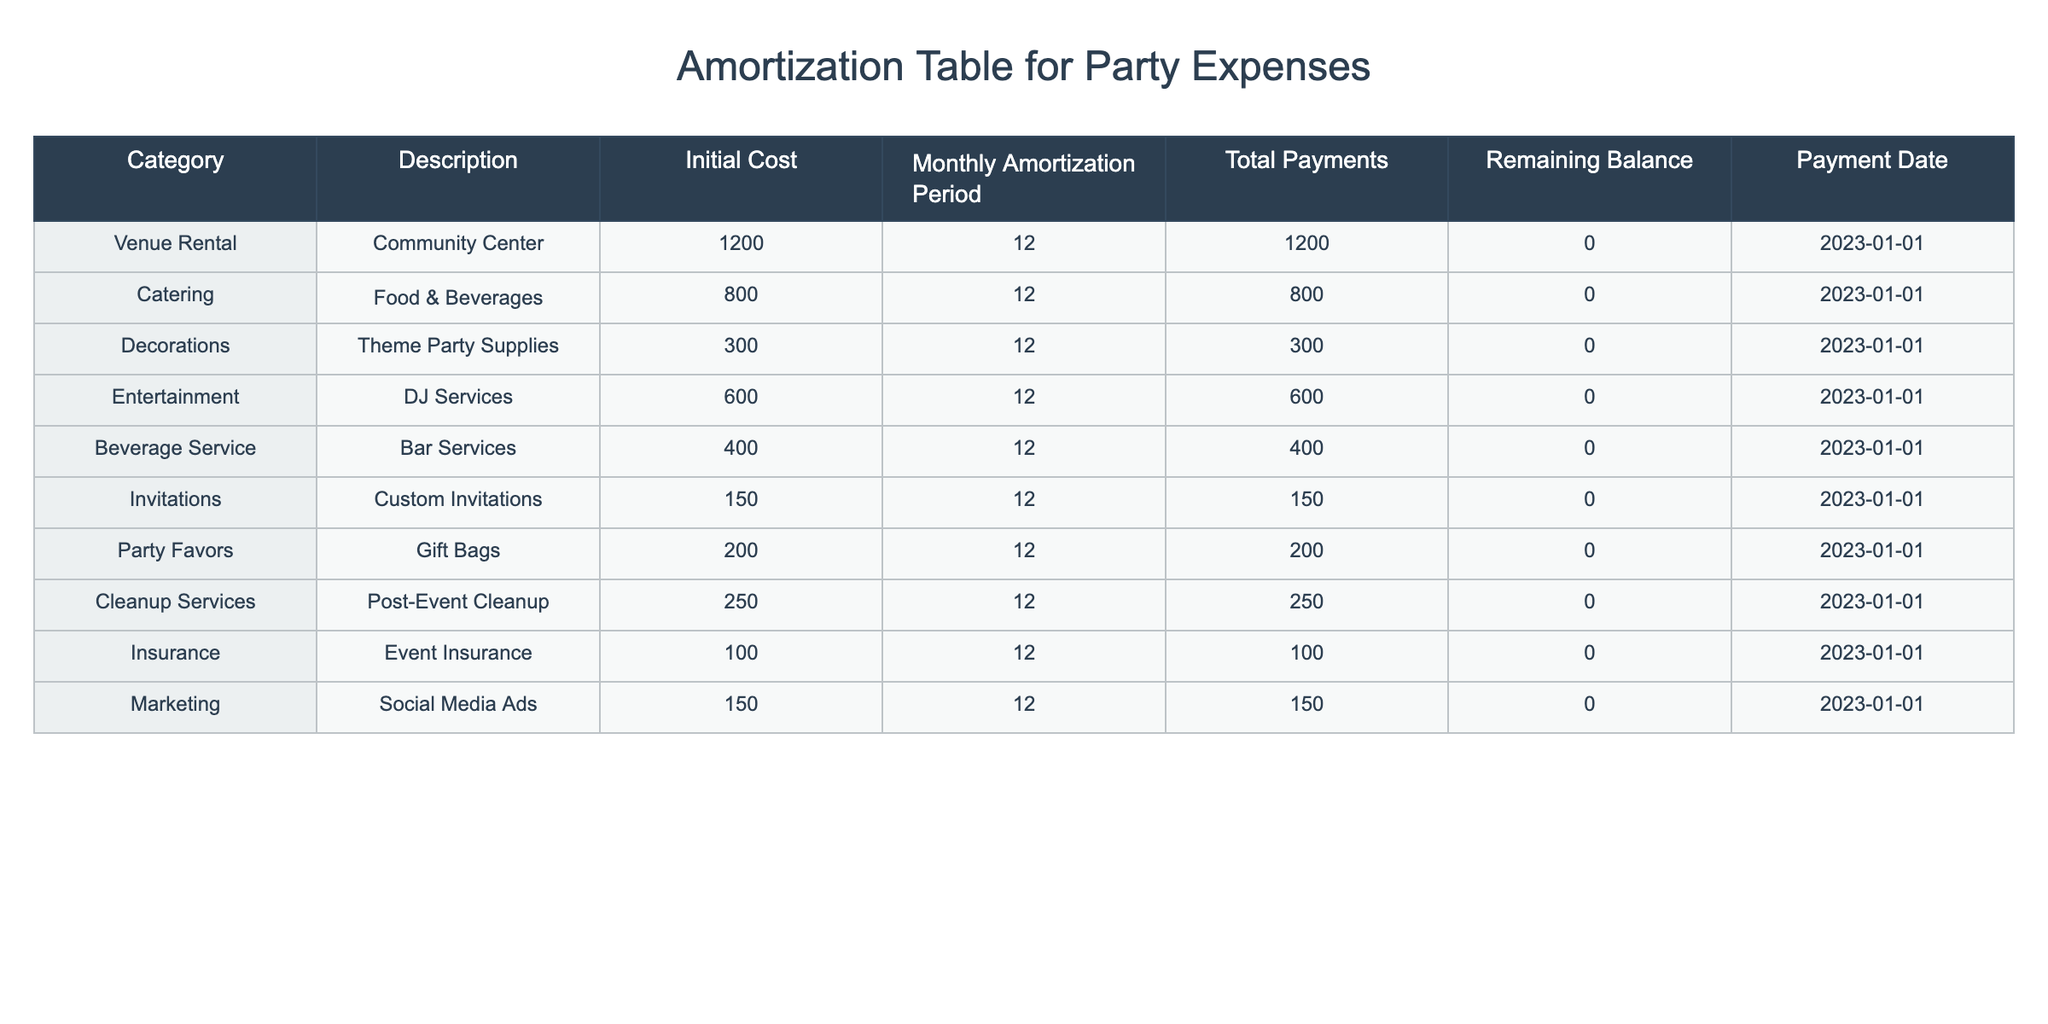What is the total initial cost of all party-related expenses? To find the total initial cost, we add all the initial costs listed in the table: 1200 (Venue Rental) + 800 (Catering) + 300 (Decorations) + 600 (Entertainment) + 400 (Beverage Service) + 150 (Invitations) + 200 (Party Favors) + 250 (Cleanup Services) + 100 (Insurance) + 150 (Marketing) = 3950.
Answer: 3950 How much will you spend on catering each month? The table indicates that the monthly amortization payment for Catering (Food & Beverages) is 800.
Answer: 800 Is the total payment for decorations the same as the initial cost? Yes, the total payment for Decorations is listed as 300, which is equal to the initial cost of 300.
Answer: Yes What are the two most expensive categories of expenses? For determining the two most expensive categories, we look at the initial costs: Venue Rental (1200) and Catering (800) are the highest values.
Answer: Venue Rental and Catering What is the total amount spent on services that require cleanup after the events? The only category that mentions cleanup is Cleanup Services, which has an initial cost of 250 and total payments of 250. Therefore, the total amount spent on cleanup is 250.
Answer: 250 Are the initial costs for Party Favors and Invitations combined greater than 400? The initial cost for Party Favors is 200 and Invitations is 150. Adding these gives us 200 + 150 = 350, which is less than 400.
Answer: No What is the average monthly amortization payment for all categories? To find the average, we calculate the total monthly amortization payments: 1200 + 800 + 300 + 600 + 400 + 150 + 200 + 250 + 100 + 150 = 3950. There are 10 categories, so the average is 3950 / 10 = 395.
Answer: 395 How much more is spent on Entertainment compared to Marketing? The cost for Entertainment is 600, and for Marketing, it is 150. The difference is 600 - 150 = 450, meaning 450 more is spent on Entertainment.
Answer: 450 Is the monthly payment for the Beverage Service less than the monthly payment for Invitations? The monthly payment for Beverage Service is 400, while for Invitations, it is 150. Since 400 is greater than 150, this statement is false.
Answer: No 